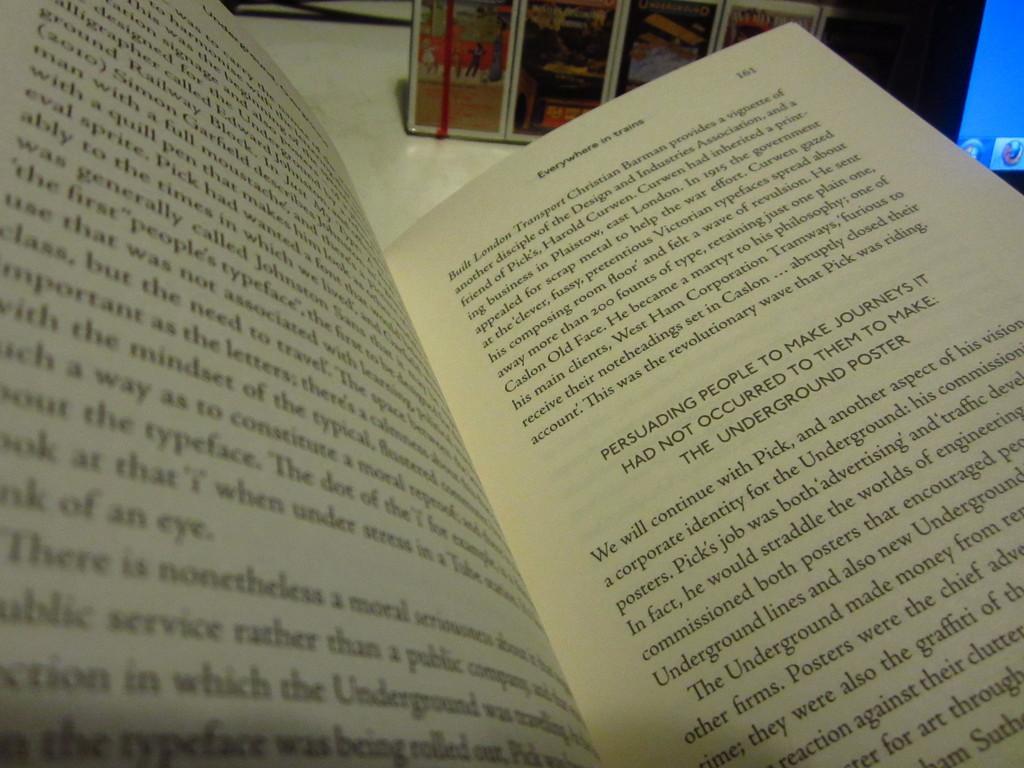<image>
Offer a succinct explanation of the picture presented. A textbook open to a page titled Everywhere in Trains. 